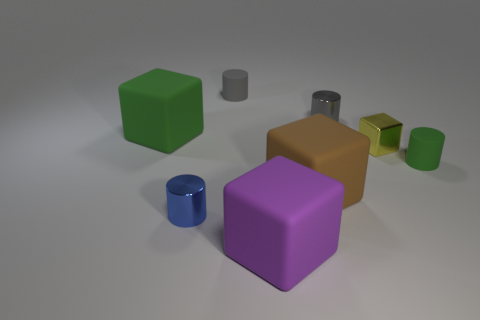Subtract 1 cylinders. How many cylinders are left? 3 Add 1 small green metallic spheres. How many objects exist? 9 Subtract all yellow cylinders. Subtract all red spheres. How many cylinders are left? 4 Subtract all gray rubber things. Subtract all green rubber cylinders. How many objects are left? 6 Add 4 small gray rubber objects. How many small gray rubber objects are left? 5 Add 8 large purple rubber cubes. How many large purple rubber cubes exist? 9 Subtract 0 brown cylinders. How many objects are left? 8 